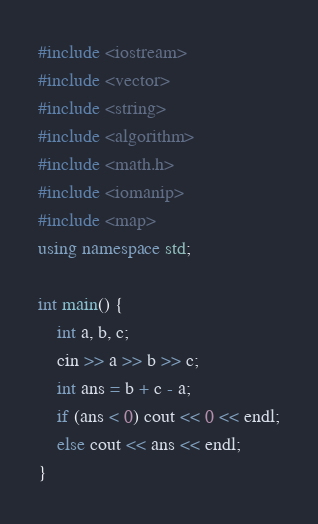Convert code to text. <code><loc_0><loc_0><loc_500><loc_500><_C++_>#include <iostream>
#include <vector>
#include <string>
#include <algorithm>
#include <math.h>
#include <iomanip>
#include <map>
using namespace std;

int main() {
    int a, b, c;
    cin >> a >> b >> c;
    int ans = b + c - a;
    if (ans < 0) cout << 0 << endl;
    else cout << ans << endl;
}
</code> 